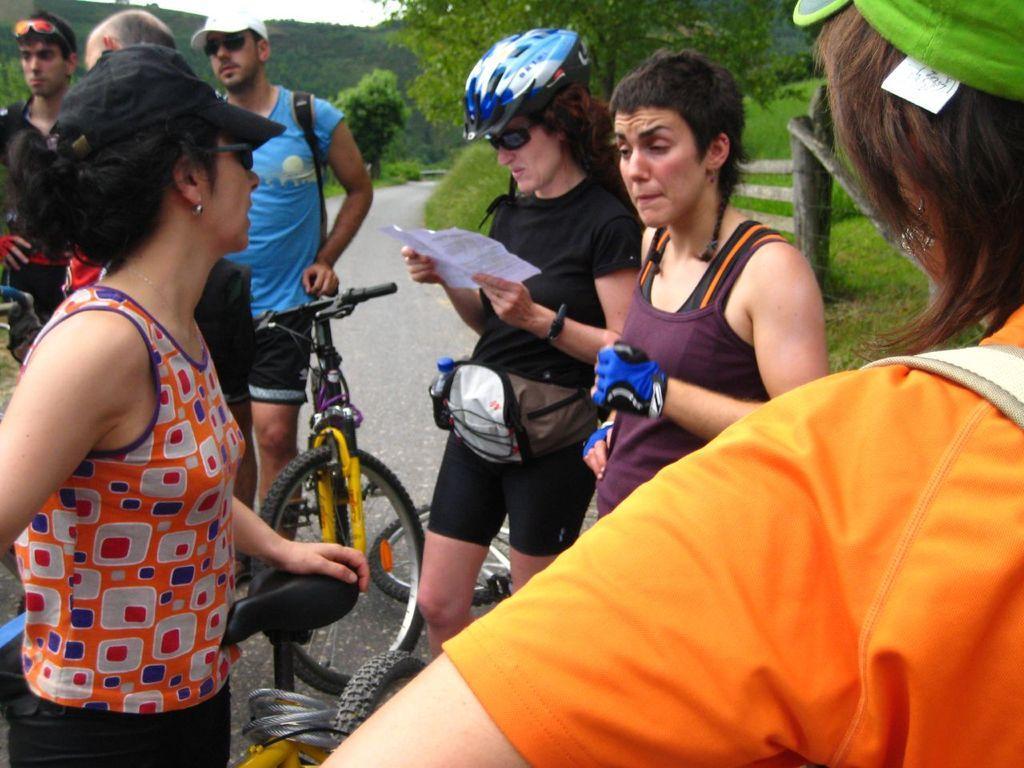How would you summarize this image in a sentence or two? In this image I can see a group of people are standing on the road, some are wearing helmet and hats. I can also see there are few trees, a bicycle on the road 